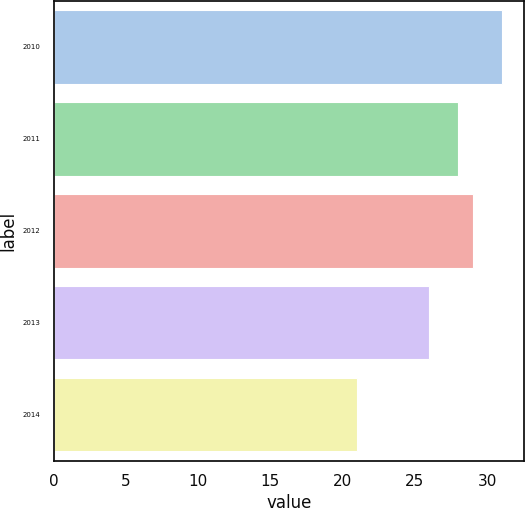Convert chart. <chart><loc_0><loc_0><loc_500><loc_500><bar_chart><fcel>2010<fcel>2011<fcel>2012<fcel>2013<fcel>2014<nl><fcel>31<fcel>28<fcel>29<fcel>26<fcel>21<nl></chart> 